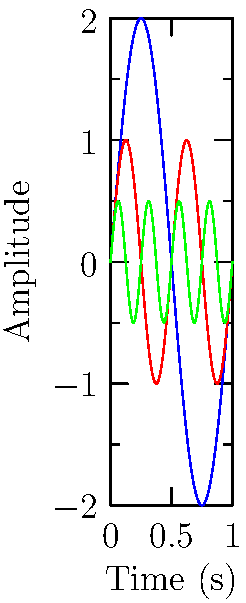As a music enthusiast visiting your favorite bar, you notice a graph displaying sound waves of different instruments. Which instrument has the highest frequency and which has the greatest amplitude? To answer this question, we need to analyze the graph for frequency and amplitude:

1. Frequency:
   - Frequency is represented by the number of complete cycles per unit time.
   - The Flute (green) has the most cycles in the given time frame.
   - The Piano (red) has the second most cycles.
   - The Guitar (blue) has the least cycles.
   - Therefore, the Flute has the highest frequency.

2. Amplitude:
   - Amplitude is the maximum displacement from the equilibrium position.
   - The Guitar (blue) wave reaches the highest and lowest points on the y-axis.
   - The Piano (red) wave has the second largest displacement.
   - The Flute (green) wave has the smallest displacement.
   - Therefore, the Guitar has the greatest amplitude.
Answer: Highest frequency: Flute; Greatest amplitude: Guitar 